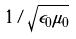<formula> <loc_0><loc_0><loc_500><loc_500>1 / \sqrt { \epsilon _ { 0 } \mu _ { 0 } }</formula> 